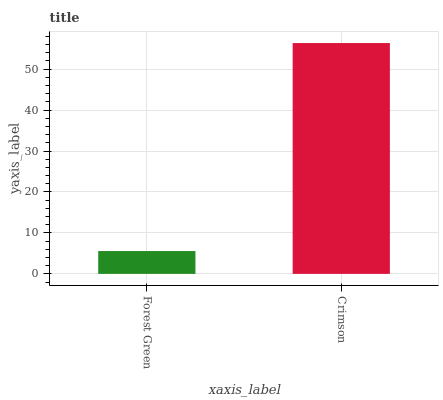Is Forest Green the minimum?
Answer yes or no. Yes. Is Crimson the maximum?
Answer yes or no. Yes. Is Crimson the minimum?
Answer yes or no. No. Is Crimson greater than Forest Green?
Answer yes or no. Yes. Is Forest Green less than Crimson?
Answer yes or no. Yes. Is Forest Green greater than Crimson?
Answer yes or no. No. Is Crimson less than Forest Green?
Answer yes or no. No. Is Crimson the high median?
Answer yes or no. Yes. Is Forest Green the low median?
Answer yes or no. Yes. Is Forest Green the high median?
Answer yes or no. No. Is Crimson the low median?
Answer yes or no. No. 